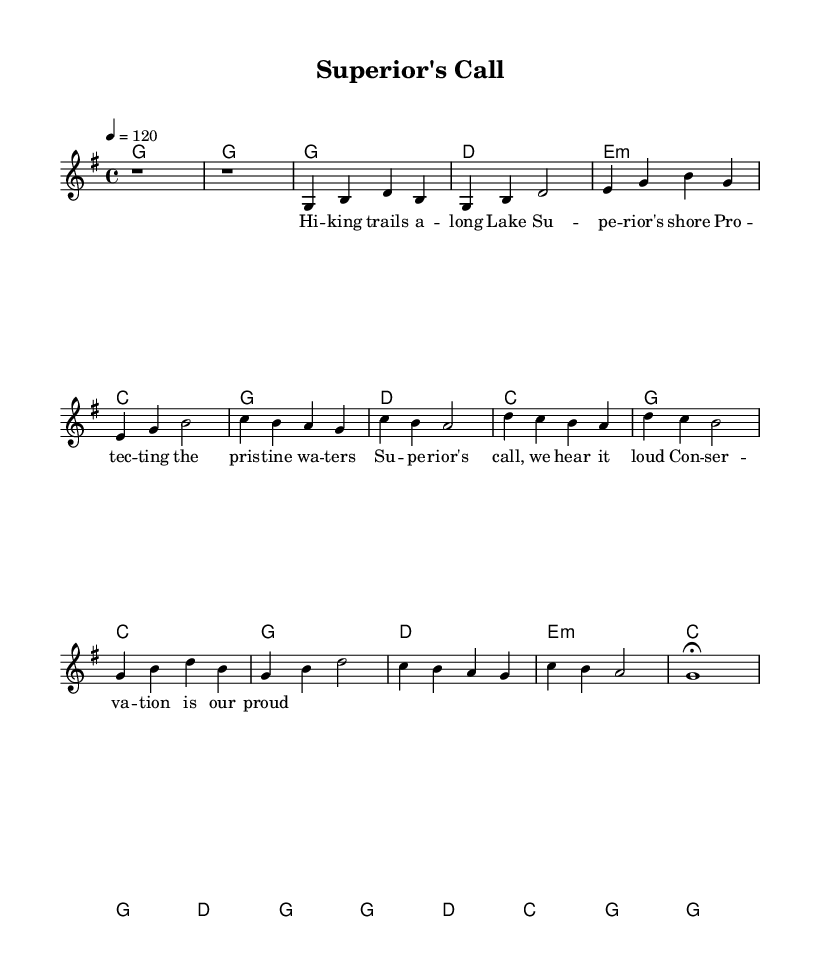What is the key signature of this music? The key signature is G major, which has one sharp (F#). This can be determined by looking at the key signature notation in the beginning of the sheet music.
Answer: G major What is the time signature of this music? The time signature is 4/4, indicated at the beginning of the score. It tells us there are 4 beats per measure and the quarter note gets one beat.
Answer: 4/4 What is the tempo marking for this piece? The tempo marking is 120 beats per minute, shown as "4 = 120" in the global setting. This indicates how fast the piece should be played.
Answer: 120 How many measures are in the first verse? The first verse consists of 4 measures. Counting the measures from the melody indicated in the verse section confirms this.
Answer: 4 What is the lyrical theme of the chorus? The theme of the chorus centers on conservation and pride in protecting environmental resources. Analysis of the lyrics reveals this connection to outdoor experiences and environmental conservation.
Answer: Conservation In which section do we find the phrase "Superior's call, we hear it loud"? This phrase is found in the chorus section, as indicated in the lyrics part of the sheet music. Understanding how verses and choruses are structured helps identify where they appear.
Answer: Chorus What type of chords primarily accompany the chorus? The primary chords in the chorus are C, G, D, and E minor. Observing the chord changes alongside the lyrics reveals the harmony supporting the melody.
Answer: C, G, D, E minor 